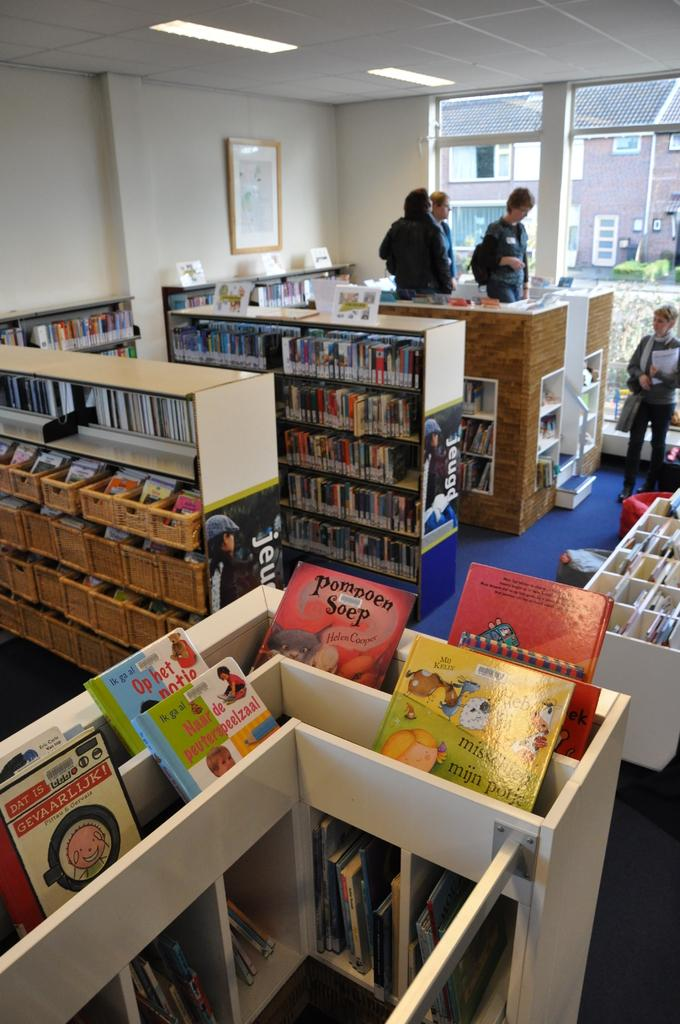<image>
Provide a brief description of the given image. The book pompeon soep rests in a bin at a book store. 